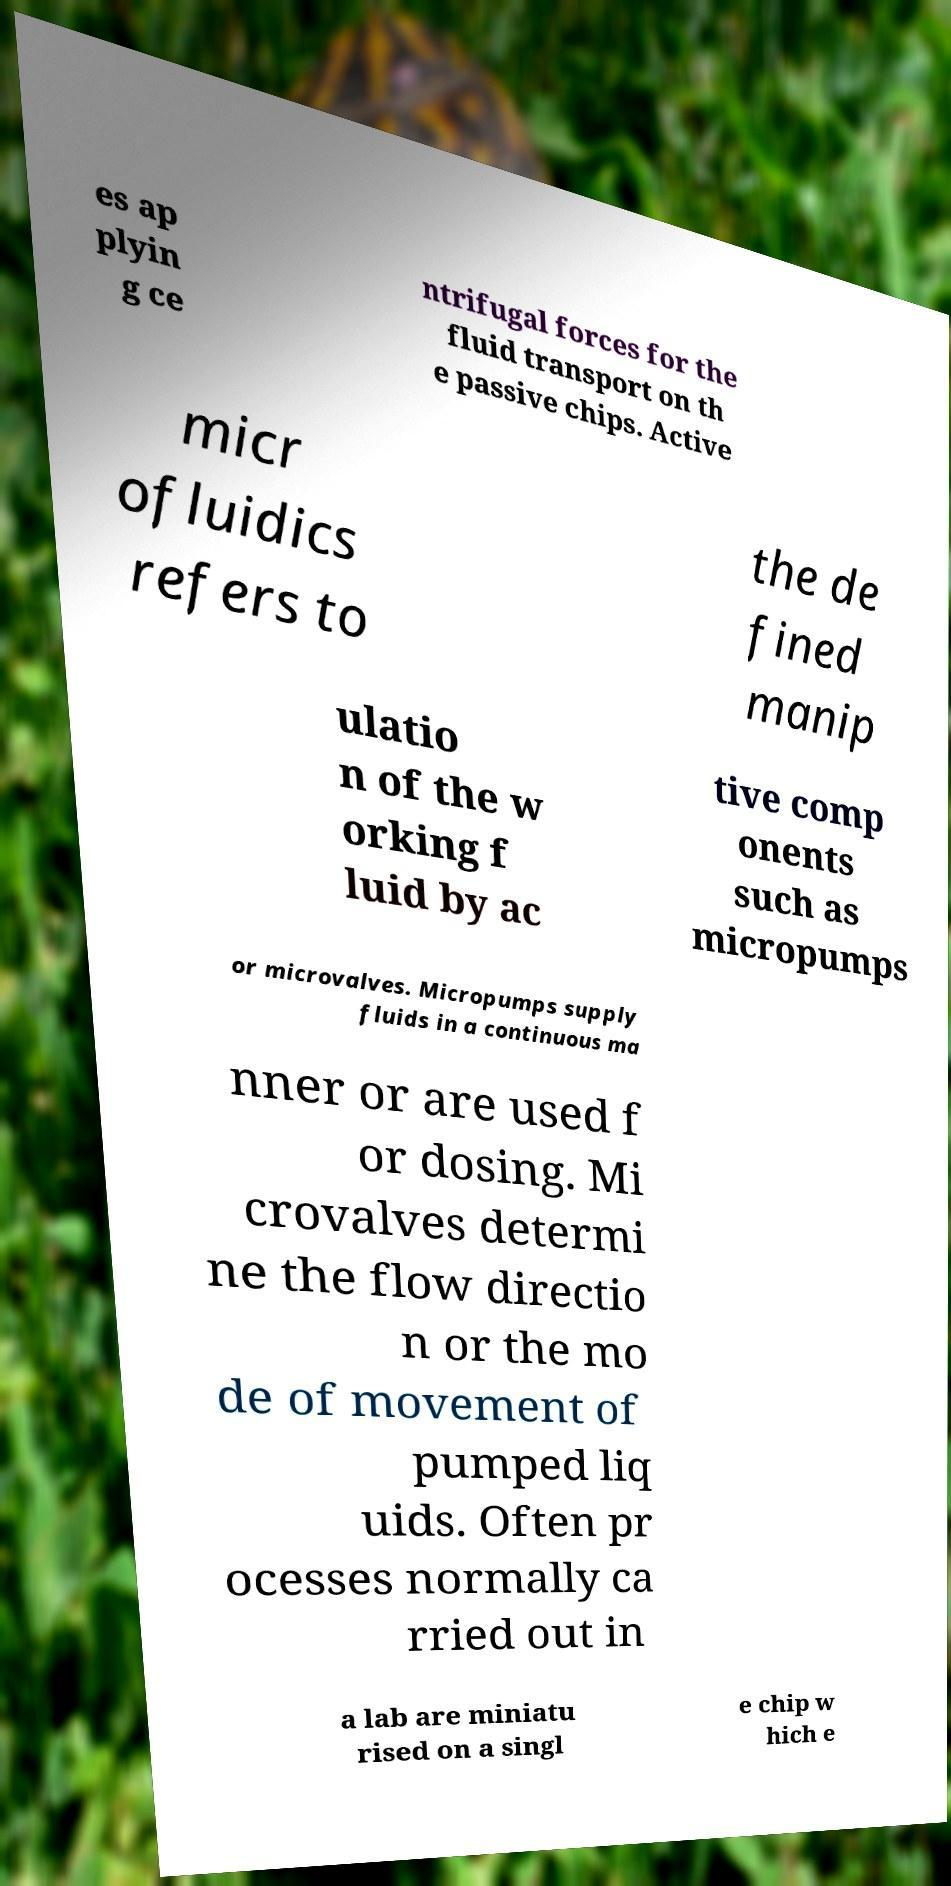I need the written content from this picture converted into text. Can you do that? es ap plyin g ce ntrifugal forces for the fluid transport on th e passive chips. Active micr ofluidics refers to the de fined manip ulatio n of the w orking f luid by ac tive comp onents such as micropumps or microvalves. Micropumps supply fluids in a continuous ma nner or are used f or dosing. Mi crovalves determi ne the flow directio n or the mo de of movement of pumped liq uids. Often pr ocesses normally ca rried out in a lab are miniatu rised on a singl e chip w hich e 